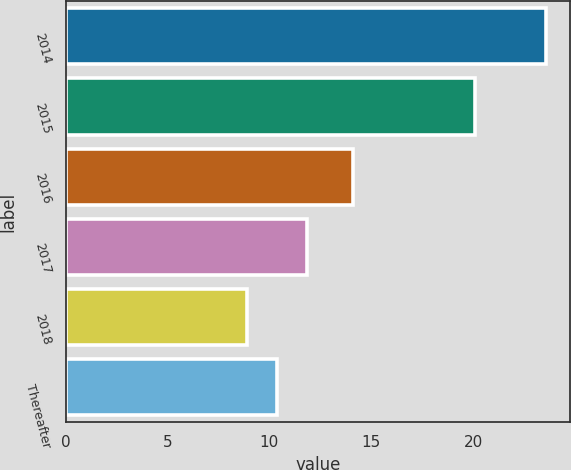Convert chart. <chart><loc_0><loc_0><loc_500><loc_500><bar_chart><fcel>2014<fcel>2015<fcel>2016<fcel>2017<fcel>2018<fcel>Thereafter<nl><fcel>23.6<fcel>20.1<fcel>14.1<fcel>11.84<fcel>8.9<fcel>10.37<nl></chart> 